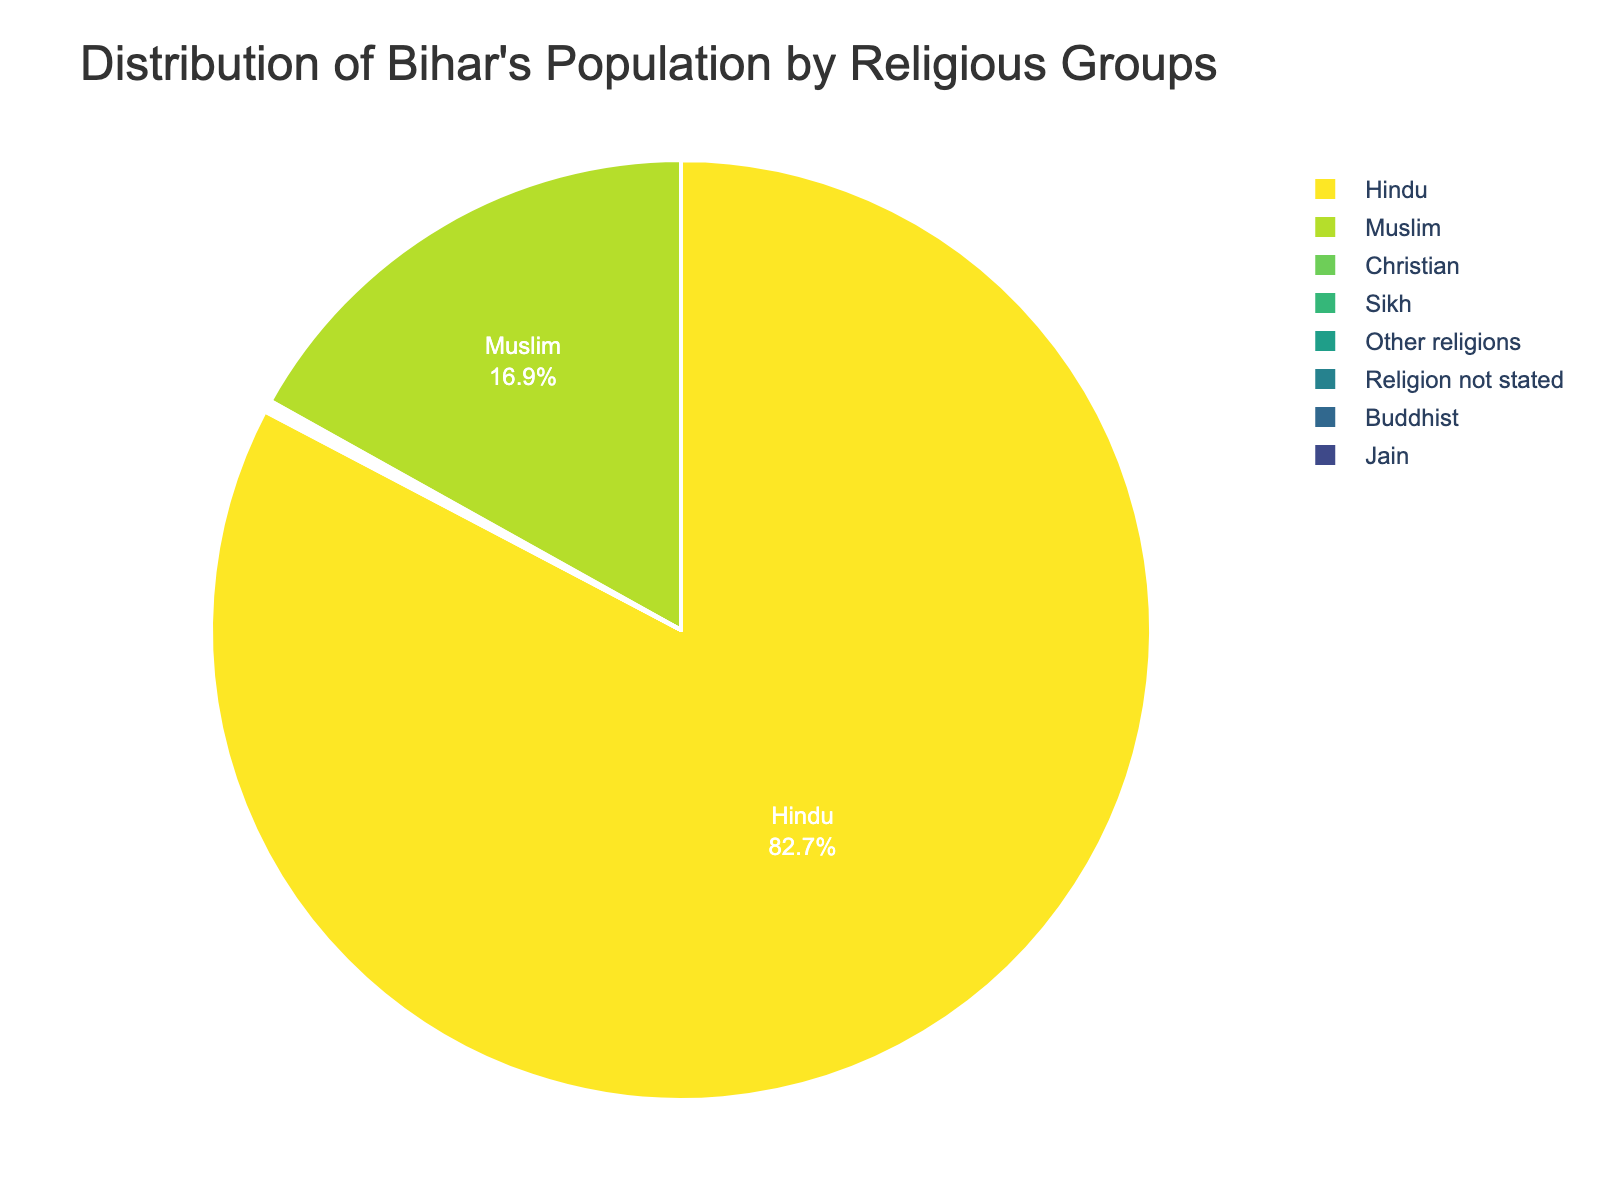What percentage of Bihar's population is Hindu? The pie chart shows different religious groups and their respective percentages. Look for the section labeled "Hindu" and note its percentage.
Answer: 82.7% Which two religious groups have the smallest populations in Bihar? Identify the two smallest percentages shown in the pie chart. These represent the religious groups with the smallest populations.
Answer: Buddhist, Jain What is the combined percentage of Christians and Sikhs in Bihar? Locate and sum the percentages for Christians and Sikhs.
Answer: 0.1 + 0.1 = 0.2 Are there more Muslims or people from "other religions" in Bihar? Compare the percentages for Muslims and "other religions."
Answer: Muslims What's the difference in population percentage between Muslims and Hindus in Bihar? Subtract the percentage of Muslims from the percentage of Hindus.
Answer: 82.7 - 16.9 = 65.8 Which religious group constitutes less than 1% of Bihar's population but more than 0.05%? Identify the religious group(s) with a percentage between 0.05% and 1% by reviewing the pie chart.
Answer: Religion not stated If the population of Bihar is approximately 104 million, how many people are Jains? Multiply the total population by the percentage of Jains (as a decimal): 104 million * 0.02/100.
Answer: Approximately 20,800 What visual characteristic identifies the majority religion in Bihar? The majority religion's section will likely be the largest and occupy the most space in the pie chart.
Answer: Largest section size Which religious group shows the least percentage on the pie chart? Identify the smallest percentage displayed.
Answer: Buddhist, Jain If the "Religion not stated" group doubled in population, what would be its new percentage? Double the current percentage of the "Religion not stated" group and note the new value.
Answer: 0.06 * 2 = 0.12 